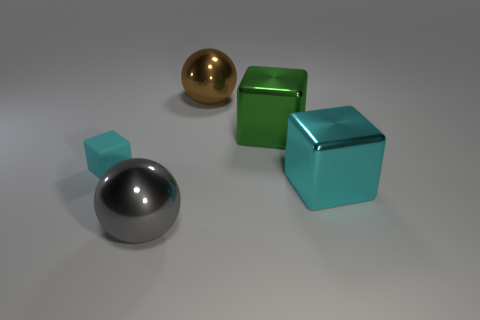Can you tell me the colors of the objects and describe their finishes? Certainly! In the image, there are four objects with distinct colors and finishes. A large sphere with a reflective chrome finish, a small sphere with a matte turquoise finish, a large cube with a reflective green finish, and a small cube with a reflective turquoise finish. 